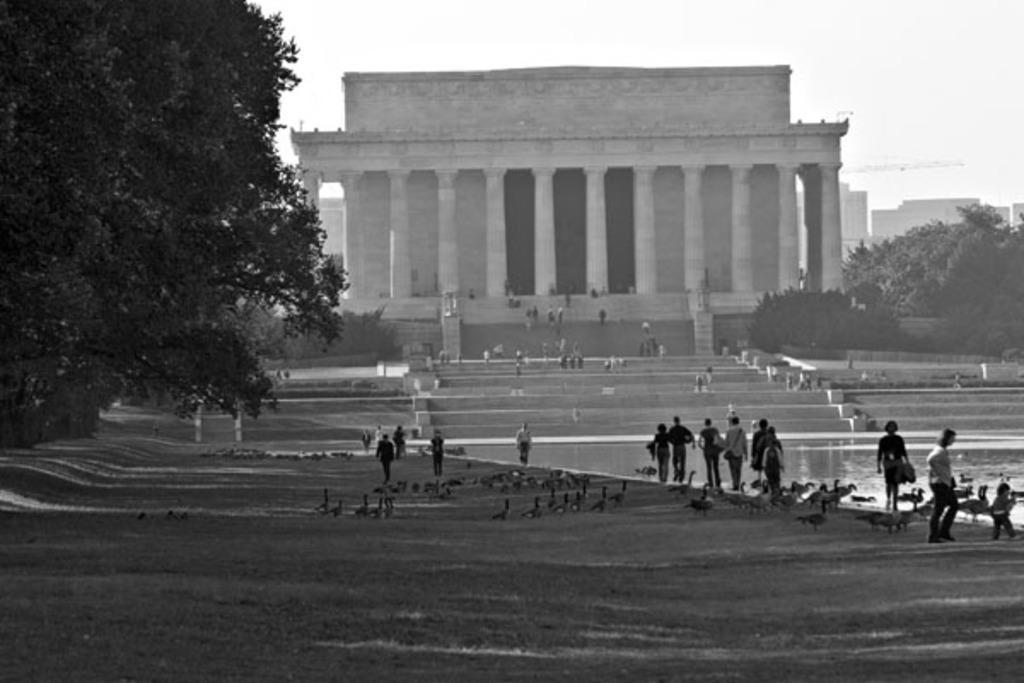Please provide a concise description of this image. This is a black and white image, in this image there is a garden, on that there are people walking and there are ducks, beside that there is a pond in that there are ducks, in the background there is a building, trees and the sky. 